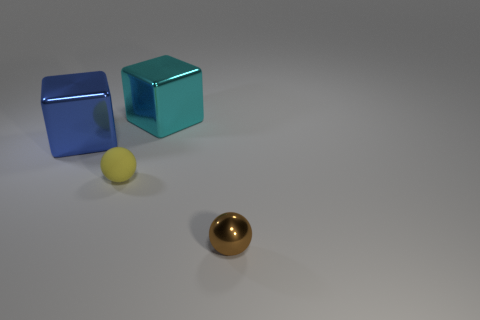There is a object that is in front of the big blue object and left of the tiny shiny thing; what is its shape?
Your response must be concise. Sphere. What number of objects are both right of the rubber sphere and in front of the big blue shiny object?
Give a very brief answer. 1. There is a tiny ball that is right of the big cyan thing; what material is it?
Your answer should be very brief. Metal. What size is the cyan cube that is made of the same material as the brown object?
Give a very brief answer. Large. What number of objects are either small yellow matte things or big blue metallic things?
Your answer should be compact. 2. What color is the large metal cube on the left side of the yellow matte ball?
Your answer should be compact. Blue. The cyan metal thing that is the same shape as the blue shiny object is what size?
Offer a terse response. Large. How many things are either large metal things that are right of the small yellow ball or large things to the left of the small yellow thing?
Your answer should be compact. 2. How big is the object that is to the left of the cyan metallic object and in front of the blue cube?
Give a very brief answer. Small. Do the tiny rubber thing and the shiny object in front of the blue metal object have the same shape?
Your answer should be very brief. Yes. 